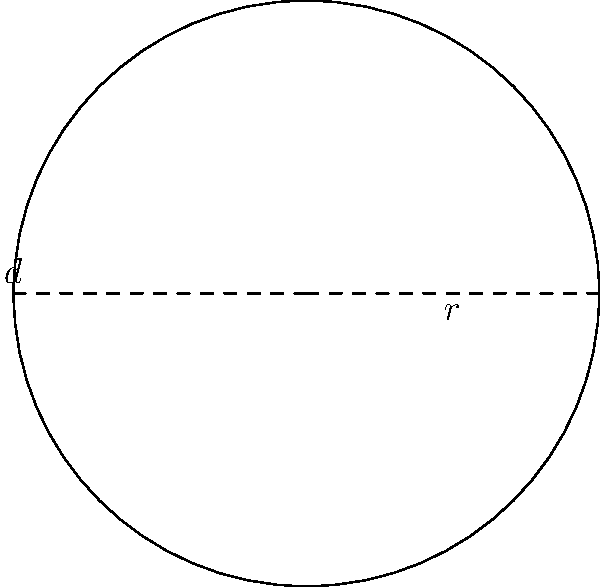For an upcoming fitness challenge, your military spouse support group wants to create a circular running track. The track has a diameter of 100 meters. What is the circumference of this track to the nearest meter? Let's approach this step-by-step:

1) First, recall the formula for the circumference of a circle:
   $C = 2\pi r$ or $C = \pi d$
   where $C$ is circumference, $r$ is radius, and $d$ is diameter.

2) We're given the diameter, so let's use the formula $C = \pi d$.

3) We know that $d = 100$ meters.

4) Let's substitute this into our formula:
   $C = \pi \times 100$

5) $\pi$ is approximately 3.14159...

6) So, $C \approx 3.14159 \times 100 = 314.159$ meters

7) Rounding to the nearest meter, we get 314 meters.
Answer: 314 meters 